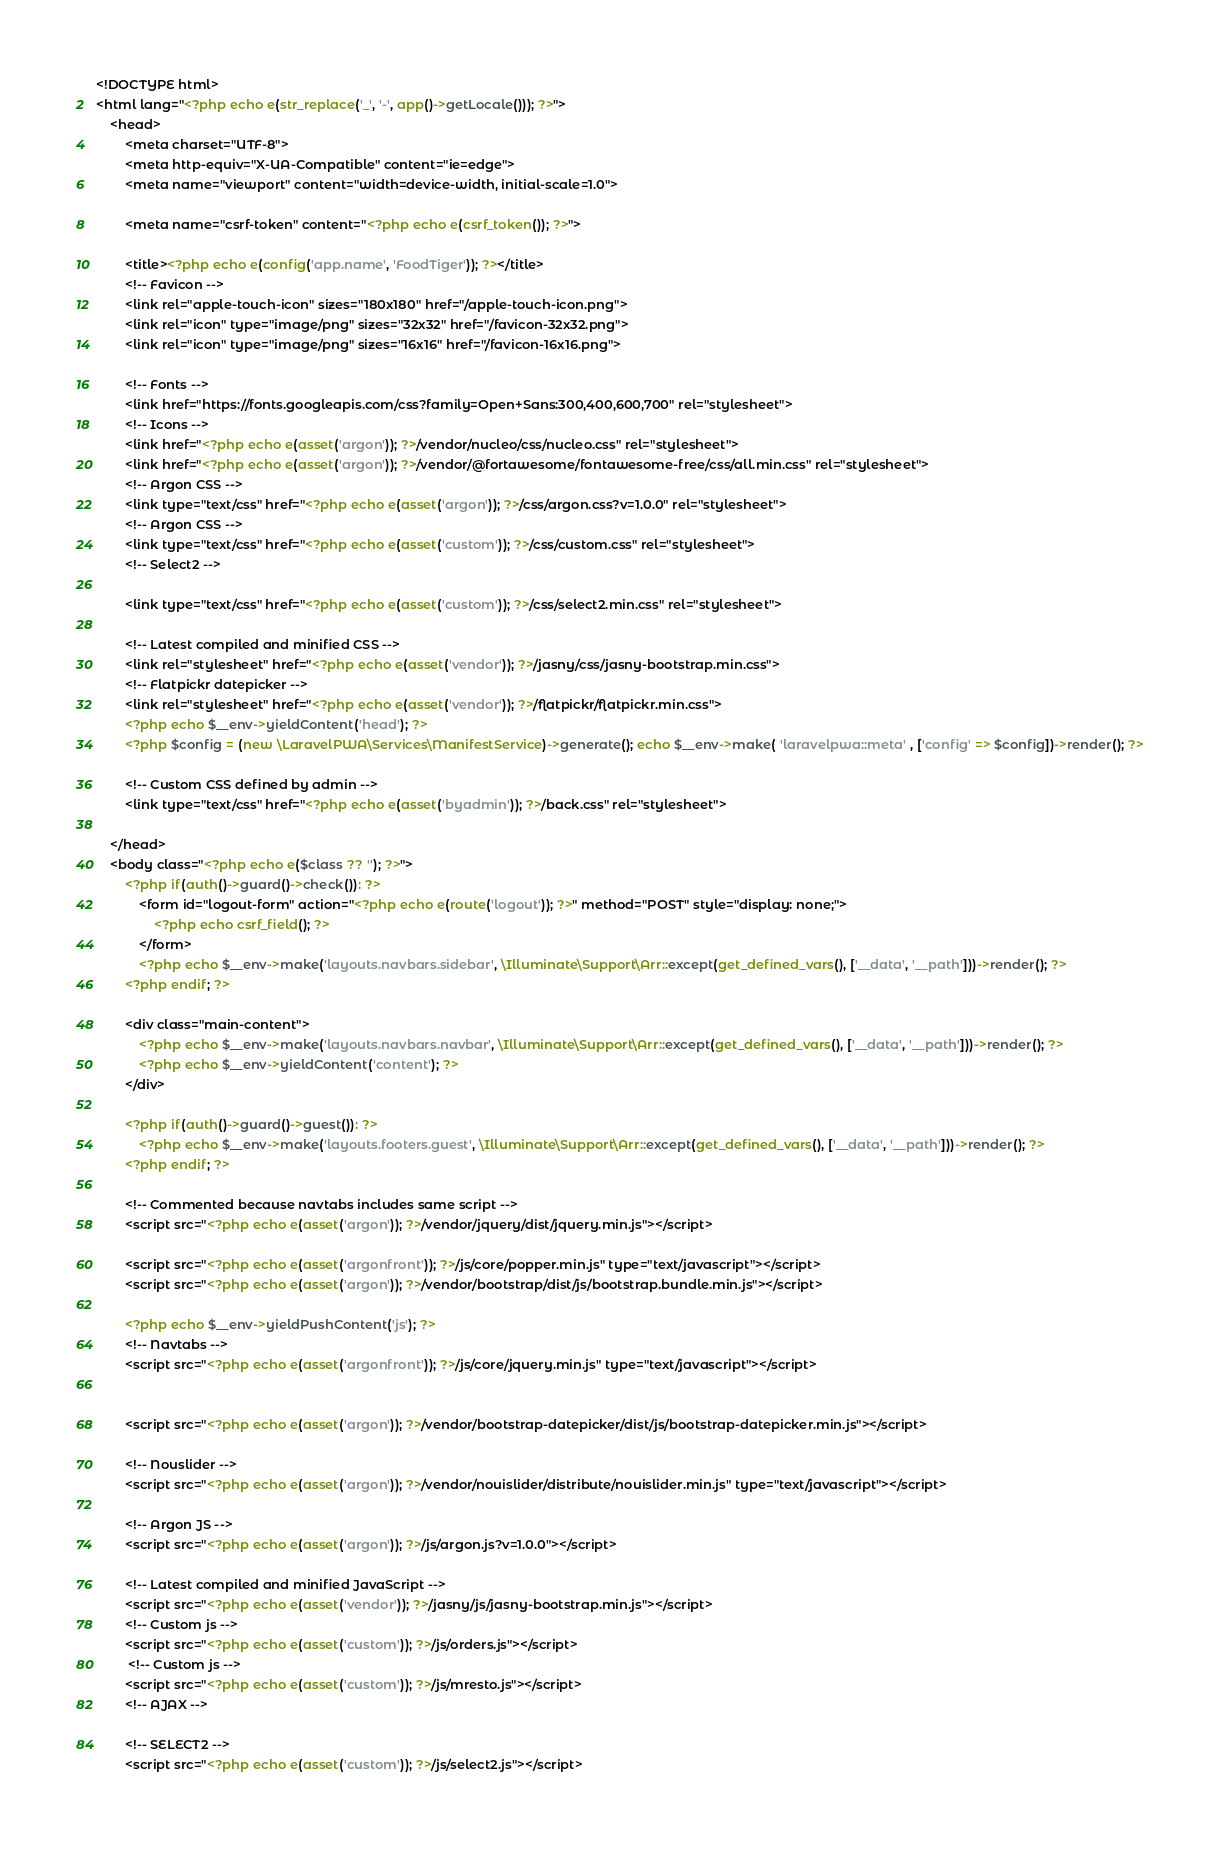<code> <loc_0><loc_0><loc_500><loc_500><_PHP_><!DOCTYPE html>
<html lang="<?php echo e(str_replace('_', '-', app()->getLocale())); ?>">
    <head>
        <meta charset="UTF-8">
        <meta http-equiv="X-UA-Compatible" content="ie=edge">
        <meta name="viewport" content="width=device-width, initial-scale=1.0">

        <meta name="csrf-token" content="<?php echo e(csrf_token()); ?>">

        <title><?php echo e(config('app.name', 'FoodTiger')); ?></title>
        <!-- Favicon -->
        <link rel="apple-touch-icon" sizes="180x180" href="/apple-touch-icon.png">
        <link rel="icon" type="image/png" sizes="32x32" href="/favicon-32x32.png">
        <link rel="icon" type="image/png" sizes="16x16" href="/favicon-16x16.png">

        <!-- Fonts -->
        <link href="https://fonts.googleapis.com/css?family=Open+Sans:300,400,600,700" rel="stylesheet">
        <!-- Icons -->
        <link href="<?php echo e(asset('argon')); ?>/vendor/nucleo/css/nucleo.css" rel="stylesheet">
        <link href="<?php echo e(asset('argon')); ?>/vendor/@fortawesome/fontawesome-free/css/all.min.css" rel="stylesheet">
        <!-- Argon CSS -->
        <link type="text/css" href="<?php echo e(asset('argon')); ?>/css/argon.css?v=1.0.0" rel="stylesheet">
        <!-- Argon CSS -->
        <link type="text/css" href="<?php echo e(asset('custom')); ?>/css/custom.css" rel="stylesheet">
        <!-- Select2 -->
        
        <link type="text/css" href="<?php echo e(asset('custom')); ?>/css/select2.min.css" rel="stylesheet">

        <!-- Latest compiled and minified CSS -->
        <link rel="stylesheet" href="<?php echo e(asset('vendor')); ?>/jasny/css/jasny-bootstrap.min.css">
        <!-- Flatpickr datepicker -->
        <link rel="stylesheet" href="<?php echo e(asset('vendor')); ?>/flatpickr/flatpickr.min.css">
        <?php echo $__env->yieldContent('head'); ?>
        <?php $config = (new \LaravelPWA\Services\ManifestService)->generate(); echo $__env->make( 'laravelpwa::meta' , ['config' => $config])->render(); ?>

        <!-- Custom CSS defined by admin -->
        <link type="text/css" href="<?php echo e(asset('byadmin')); ?>/back.css" rel="stylesheet">
        
    </head>
    <body class="<?php echo e($class ?? ''); ?>">
        <?php if(auth()->guard()->check()): ?>
            <form id="logout-form" action="<?php echo e(route('logout')); ?>" method="POST" style="display: none;">
                <?php echo csrf_field(); ?>
            </form>
            <?php echo $__env->make('layouts.navbars.sidebar', \Illuminate\Support\Arr::except(get_defined_vars(), ['__data', '__path']))->render(); ?>
        <?php endif; ?>

        <div class="main-content">
            <?php echo $__env->make('layouts.navbars.navbar', \Illuminate\Support\Arr::except(get_defined_vars(), ['__data', '__path']))->render(); ?>
            <?php echo $__env->yieldContent('content'); ?>
        </div>

        <?php if(auth()->guard()->guest()): ?>
            <?php echo $__env->make('layouts.footers.guest', \Illuminate\Support\Arr::except(get_defined_vars(), ['__data', '__path']))->render(); ?>
        <?php endif; ?>

        <!-- Commented because navtabs includes same script -->
        <script src="<?php echo e(asset('argon')); ?>/vendor/jquery/dist/jquery.min.js"></script>

        <script src="<?php echo e(asset('argonfront')); ?>/js/core/popper.min.js" type="text/javascript"></script>
        <script src="<?php echo e(asset('argon')); ?>/vendor/bootstrap/dist/js/bootstrap.bundle.min.js"></script>

        <?php echo $__env->yieldPushContent('js'); ?>
        <!-- Navtabs -->
        <script src="<?php echo e(asset('argonfront')); ?>/js/core/jquery.min.js" type="text/javascript"></script>
        

        <script src="<?php echo e(asset('argon')); ?>/vendor/bootstrap-datepicker/dist/js/bootstrap-datepicker.min.js"></script>

        <!-- Nouslider -->
        <script src="<?php echo e(asset('argon')); ?>/vendor/nouislider/distribute/nouislider.min.js" type="text/javascript"></script>

        <!-- Argon JS -->
        <script src="<?php echo e(asset('argon')); ?>/js/argon.js?v=1.0.0"></script>

        <!-- Latest compiled and minified JavaScript -->
        <script src="<?php echo e(asset('vendor')); ?>/jasny/js/jasny-bootstrap.min.js"></script>
        <!-- Custom js -->
        <script src="<?php echo e(asset('custom')); ?>/js/orders.js"></script>
         <!-- Custom js -->
        <script src="<?php echo e(asset('custom')); ?>/js/mresto.js"></script>
        <!-- AJAX -->
        
        <!-- SELECT2 -->
        <script src="<?php echo e(asset('custom')); ?>/js/select2.js"></script></code> 